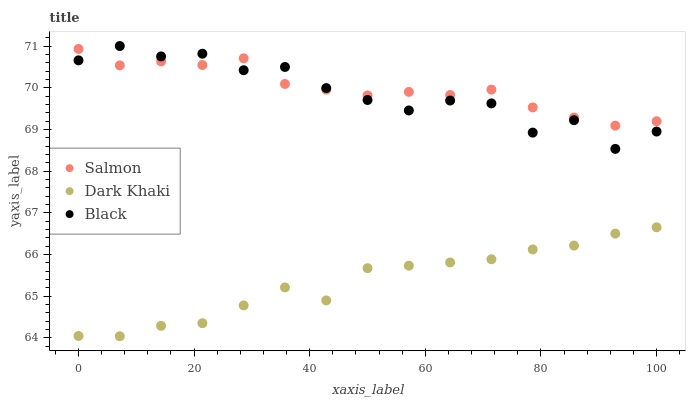Does Dark Khaki have the minimum area under the curve?
Answer yes or no. Yes. Does Salmon have the maximum area under the curve?
Answer yes or no. Yes. Does Black have the minimum area under the curve?
Answer yes or no. No. Does Black have the maximum area under the curve?
Answer yes or no. No. Is Salmon the smoothest?
Answer yes or no. Yes. Is Black the roughest?
Answer yes or no. Yes. Is Black the smoothest?
Answer yes or no. No. Is Salmon the roughest?
Answer yes or no. No. Does Dark Khaki have the lowest value?
Answer yes or no. Yes. Does Black have the lowest value?
Answer yes or no. No. Does Black have the highest value?
Answer yes or no. Yes. Does Salmon have the highest value?
Answer yes or no. No. Is Dark Khaki less than Black?
Answer yes or no. Yes. Is Black greater than Dark Khaki?
Answer yes or no. Yes. Does Salmon intersect Black?
Answer yes or no. Yes. Is Salmon less than Black?
Answer yes or no. No. Is Salmon greater than Black?
Answer yes or no. No. Does Dark Khaki intersect Black?
Answer yes or no. No. 